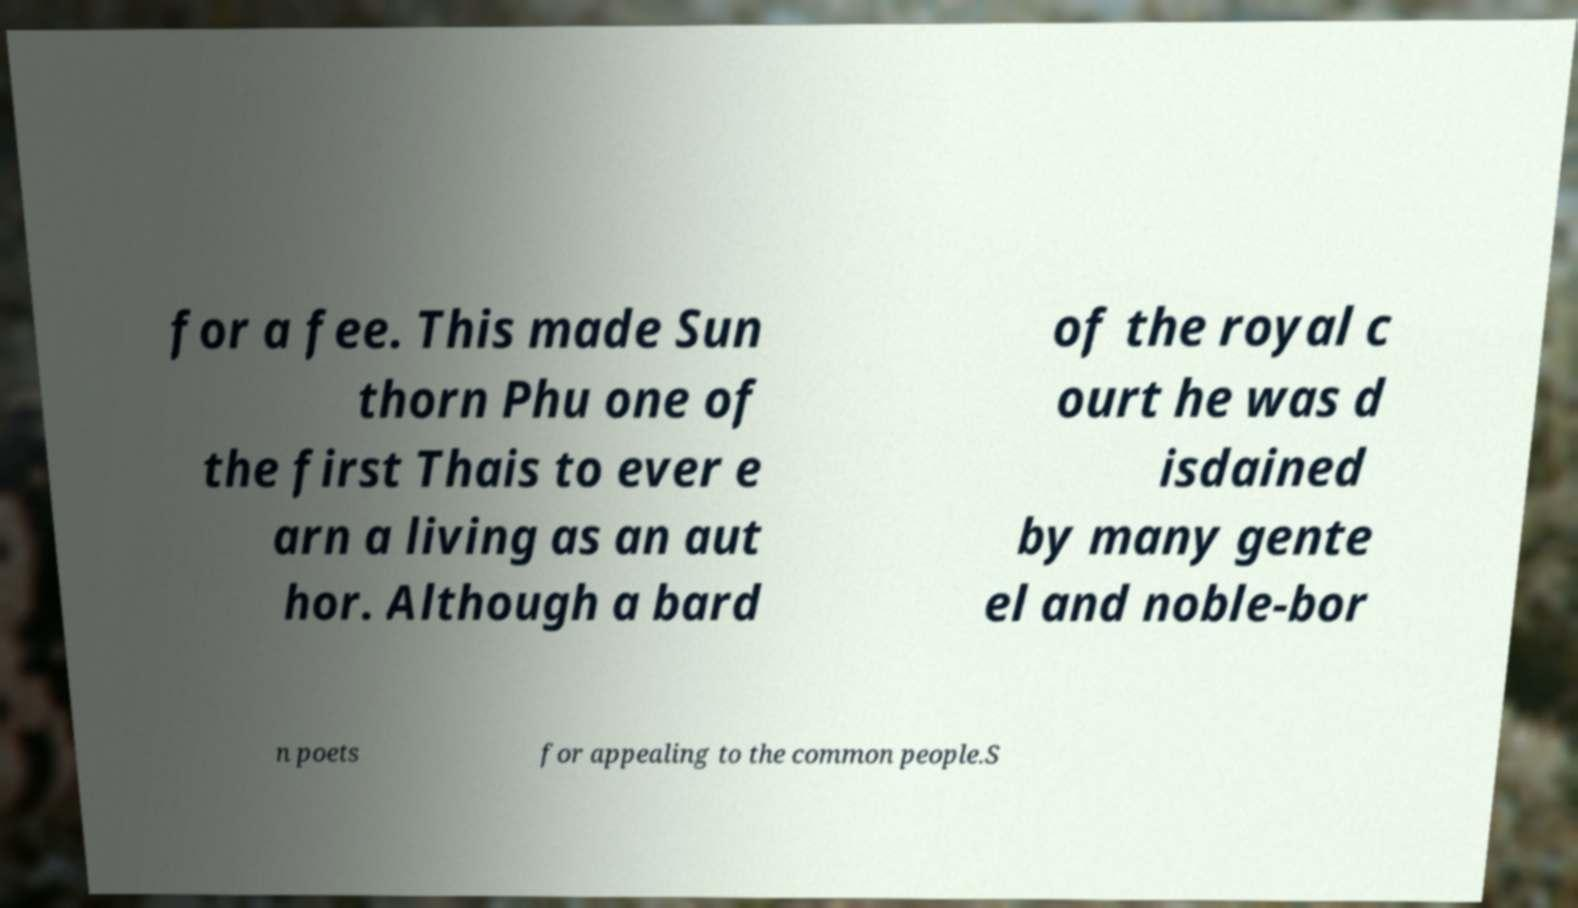What messages or text are displayed in this image? I need them in a readable, typed format. for a fee. This made Sun thorn Phu one of the first Thais to ever e arn a living as an aut hor. Although a bard of the royal c ourt he was d isdained by many gente el and noble-bor n poets for appealing to the common people.S 